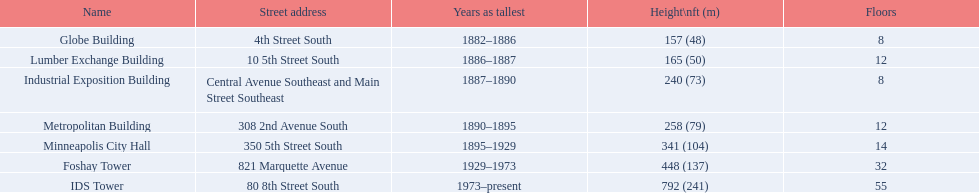In the lumber exchange building, how many floors are there? 12. Identify another building that also contains 12 floors.? Metropolitan Building. Parse the full table in json format. {'header': ['Name', 'Street address', 'Years as tallest', 'Height\\nft (m)', 'Floors'], 'rows': [['Globe Building', '4th Street South', '1882–1886', '157 (48)', '8'], ['Lumber Exchange Building', '10 5th Street South', '1886–1887', '165 (50)', '12'], ['Industrial Exposition Building', 'Central Avenue Southeast and Main Street Southeast', '1887–1890', '240 (73)', '8'], ['Metropolitan Building', '308 2nd Avenue South', '1890–1895', '258 (79)', '12'], ['Minneapolis City Hall', '350 5th Street South', '1895–1929', '341 (104)', '14'], ['Foshay Tower', '821 Marquette Avenue', '1929–1973', '448 (137)', '32'], ['IDS Tower', '80 8th Street South', '1973–present', '792 (241)', '55']]} 